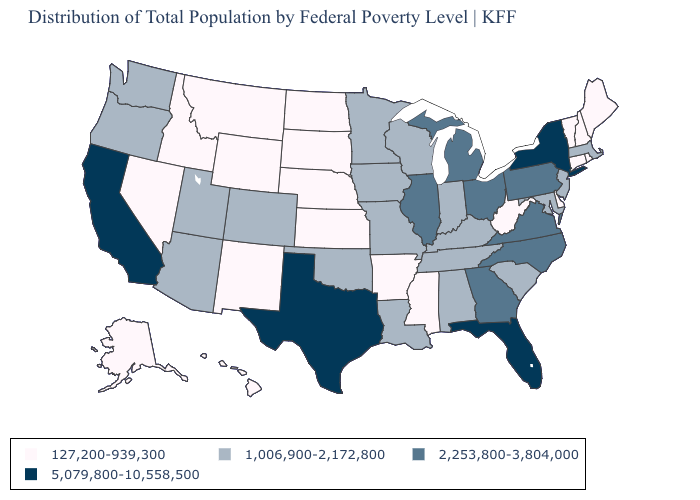What is the value of Louisiana?
Short answer required. 1,006,900-2,172,800. What is the value of Montana?
Be succinct. 127,200-939,300. Which states hav the highest value in the West?
Answer briefly. California. What is the value of Kansas?
Short answer required. 127,200-939,300. Name the states that have a value in the range 1,006,900-2,172,800?
Give a very brief answer. Alabama, Arizona, Colorado, Indiana, Iowa, Kentucky, Louisiana, Maryland, Massachusetts, Minnesota, Missouri, New Jersey, Oklahoma, Oregon, South Carolina, Tennessee, Utah, Washington, Wisconsin. Does Mississippi have the highest value in the USA?
Short answer required. No. Which states have the lowest value in the USA?
Write a very short answer. Alaska, Arkansas, Connecticut, Delaware, Hawaii, Idaho, Kansas, Maine, Mississippi, Montana, Nebraska, Nevada, New Hampshire, New Mexico, North Dakota, Rhode Island, South Dakota, Vermont, West Virginia, Wyoming. What is the value of Arkansas?
Write a very short answer. 127,200-939,300. Name the states that have a value in the range 1,006,900-2,172,800?
Concise answer only. Alabama, Arizona, Colorado, Indiana, Iowa, Kentucky, Louisiana, Maryland, Massachusetts, Minnesota, Missouri, New Jersey, Oklahoma, Oregon, South Carolina, Tennessee, Utah, Washington, Wisconsin. What is the lowest value in states that border Missouri?
Short answer required. 127,200-939,300. Name the states that have a value in the range 1,006,900-2,172,800?
Quick response, please. Alabama, Arizona, Colorado, Indiana, Iowa, Kentucky, Louisiana, Maryland, Massachusetts, Minnesota, Missouri, New Jersey, Oklahoma, Oregon, South Carolina, Tennessee, Utah, Washington, Wisconsin. What is the value of Tennessee?
Concise answer only. 1,006,900-2,172,800. Does Connecticut have the lowest value in the USA?
Quick response, please. Yes. What is the lowest value in the MidWest?
Short answer required. 127,200-939,300. Name the states that have a value in the range 1,006,900-2,172,800?
Answer briefly. Alabama, Arizona, Colorado, Indiana, Iowa, Kentucky, Louisiana, Maryland, Massachusetts, Minnesota, Missouri, New Jersey, Oklahoma, Oregon, South Carolina, Tennessee, Utah, Washington, Wisconsin. 